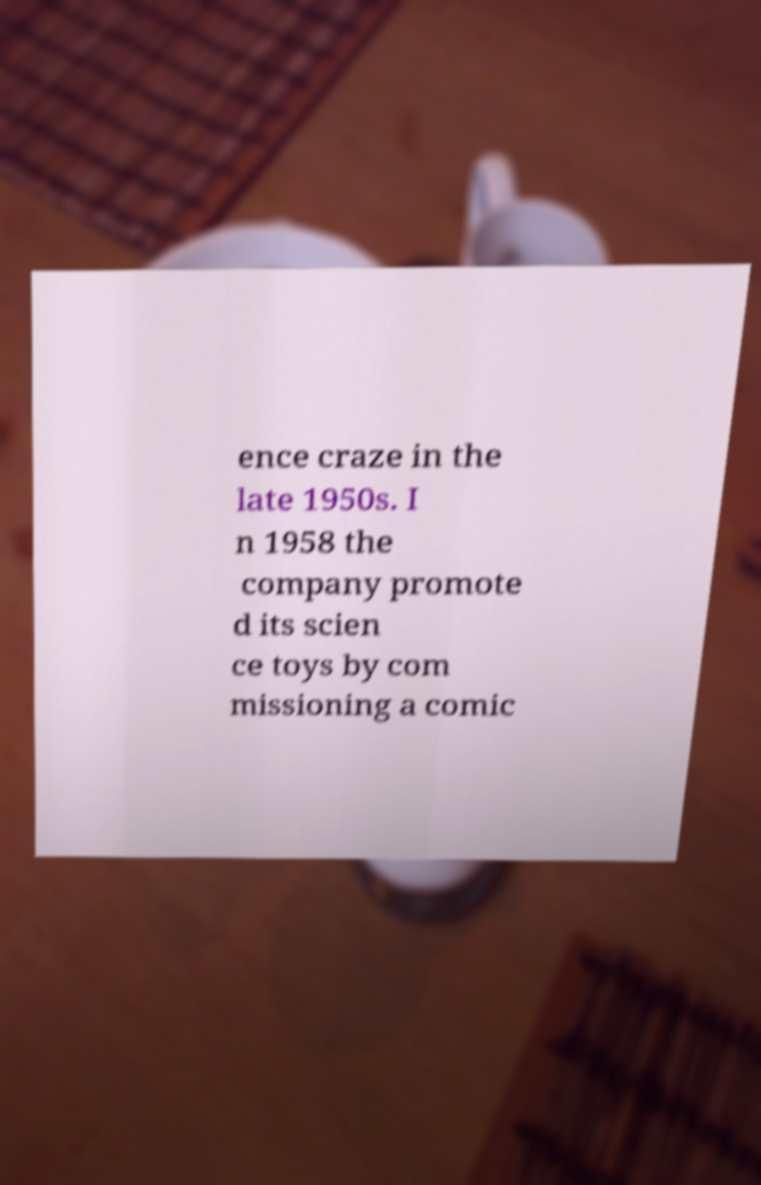For documentation purposes, I need the text within this image transcribed. Could you provide that? ence craze in the late 1950s. I n 1958 the company promote d its scien ce toys by com missioning a comic 